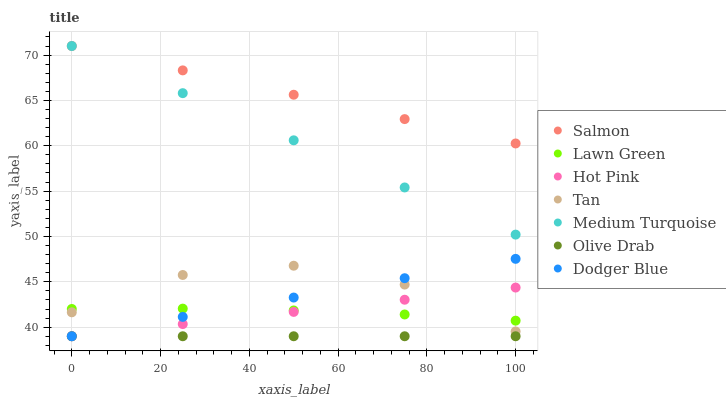Does Olive Drab have the minimum area under the curve?
Answer yes or no. Yes. Does Salmon have the maximum area under the curve?
Answer yes or no. Yes. Does Hot Pink have the minimum area under the curve?
Answer yes or no. No. Does Hot Pink have the maximum area under the curve?
Answer yes or no. No. Is Hot Pink the smoothest?
Answer yes or no. Yes. Is Tan the roughest?
Answer yes or no. Yes. Is Salmon the smoothest?
Answer yes or no. No. Is Salmon the roughest?
Answer yes or no. No. Does Hot Pink have the lowest value?
Answer yes or no. Yes. Does Salmon have the lowest value?
Answer yes or no. No. Does Medium Turquoise have the highest value?
Answer yes or no. Yes. Does Hot Pink have the highest value?
Answer yes or no. No. Is Lawn Green less than Medium Turquoise?
Answer yes or no. Yes. Is Lawn Green greater than Olive Drab?
Answer yes or no. Yes. Does Hot Pink intersect Lawn Green?
Answer yes or no. Yes. Is Hot Pink less than Lawn Green?
Answer yes or no. No. Is Hot Pink greater than Lawn Green?
Answer yes or no. No. Does Lawn Green intersect Medium Turquoise?
Answer yes or no. No. 